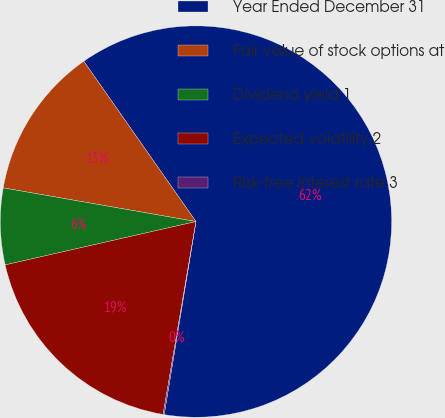<chart> <loc_0><loc_0><loc_500><loc_500><pie_chart><fcel>Year Ended December 31<fcel>Fair value of stock options at<fcel>Dividend yield 1<fcel>Expected volatility 2<fcel>Risk-free interest rate 3<nl><fcel>62.32%<fcel>12.53%<fcel>6.31%<fcel>18.76%<fcel>0.09%<nl></chart> 